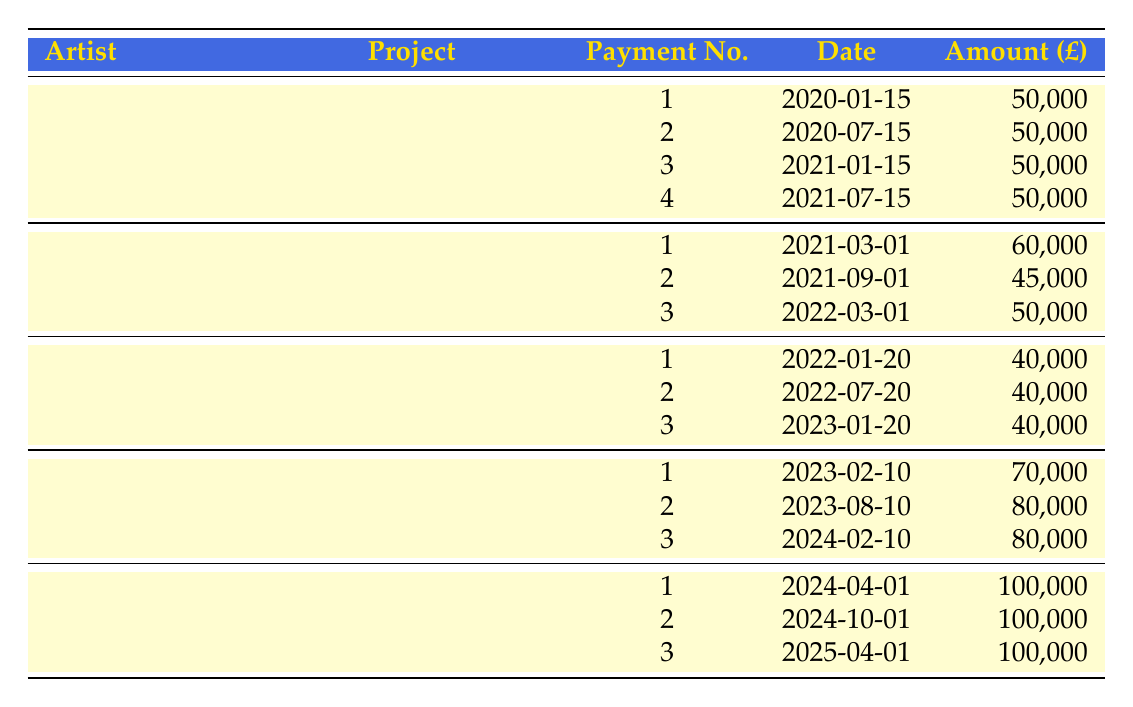What is the total payment for David Hockney's project? The table shows that David Hockney's total payment for "Portrait of Her Majesty" is £200,000. This amount is directly stated in the table.
Answer: 200000 How many payments did Tracey Emin receive? According to the payment schedule for Tracey Emin's project "The Royal Bed", there are three payments listed: £60,000, £45,000, and £50,000, indicating a total of three payments received.
Answer: 3 What is the total amount paid to Grayson Perry by January 20, 2023? Grayson Perry has three payments listed: £40,000 (on January 20, 2022), £40,000 (on July 20, 2022), and £40,000 (on January 20, 2023). Adding these amounts gives 40,000 + 40,000 + 40,000 = £120,000 total paid by that date.
Answer: 120000 Was there a payment to Banksy before 2023? By looking at the payment schedule for Banksy’s project "A Royal Disguise," the first payment occurs on February 10, 2023, which means there were no payments made prior to that date, confirming this statement is true.
Answer: No What is the average payment amount for Anish Kapoor's project? Anish Kapoor has three payments: £100,000 (on April 1, 2024), £100,000 (on October 1, 2024), and £100,000 (on April 1, 2025). To find the average, sum these amounts (100,000 + 100,000 + 100,000 = 300,000) and divide by the number of payments (3), which yields an average of 300,000 / 3 = £100,000.
Answer: 100000 What is the difference in total payment between Banksy and Tracey Emin? Banksy’s total payment is £250,000, while Tracey Emin’s total payment is £150,000. The difference is calculated by subtracting Tracey Emin’s total from Banksy's total: 250,000 - 150,000 = £100,000. Therefore, Banksy is paid £100,000 more than Tracey Emin.
Answer: 100000 Which artist has the highest payment for a single installment? Looking at the table, the highest single payment is £100,000 made to Anish Kapoor for each of his installments. Other payments do not exceed this value, thus confirming Anish Kapoor has the highest payment installment.
Answer: Anish Kapoor What is the total sum of payments due by the end of 2024 across all commissions? To find this, we consider the payments scheduled up until the end of 2024. For David Hockney, payments total £200,000; Tracey Emin totals £150,000; Grayson Perry totals £120,000; Banksy totals £150,000 (including two payments); and Anish Kapoor will have paid £100,000 (one payment in 2024). Adding these gives a total of 200,000 + 150,000 + 120,000 + 150,000 + 100,000 = £720,000.
Answer: 720000 